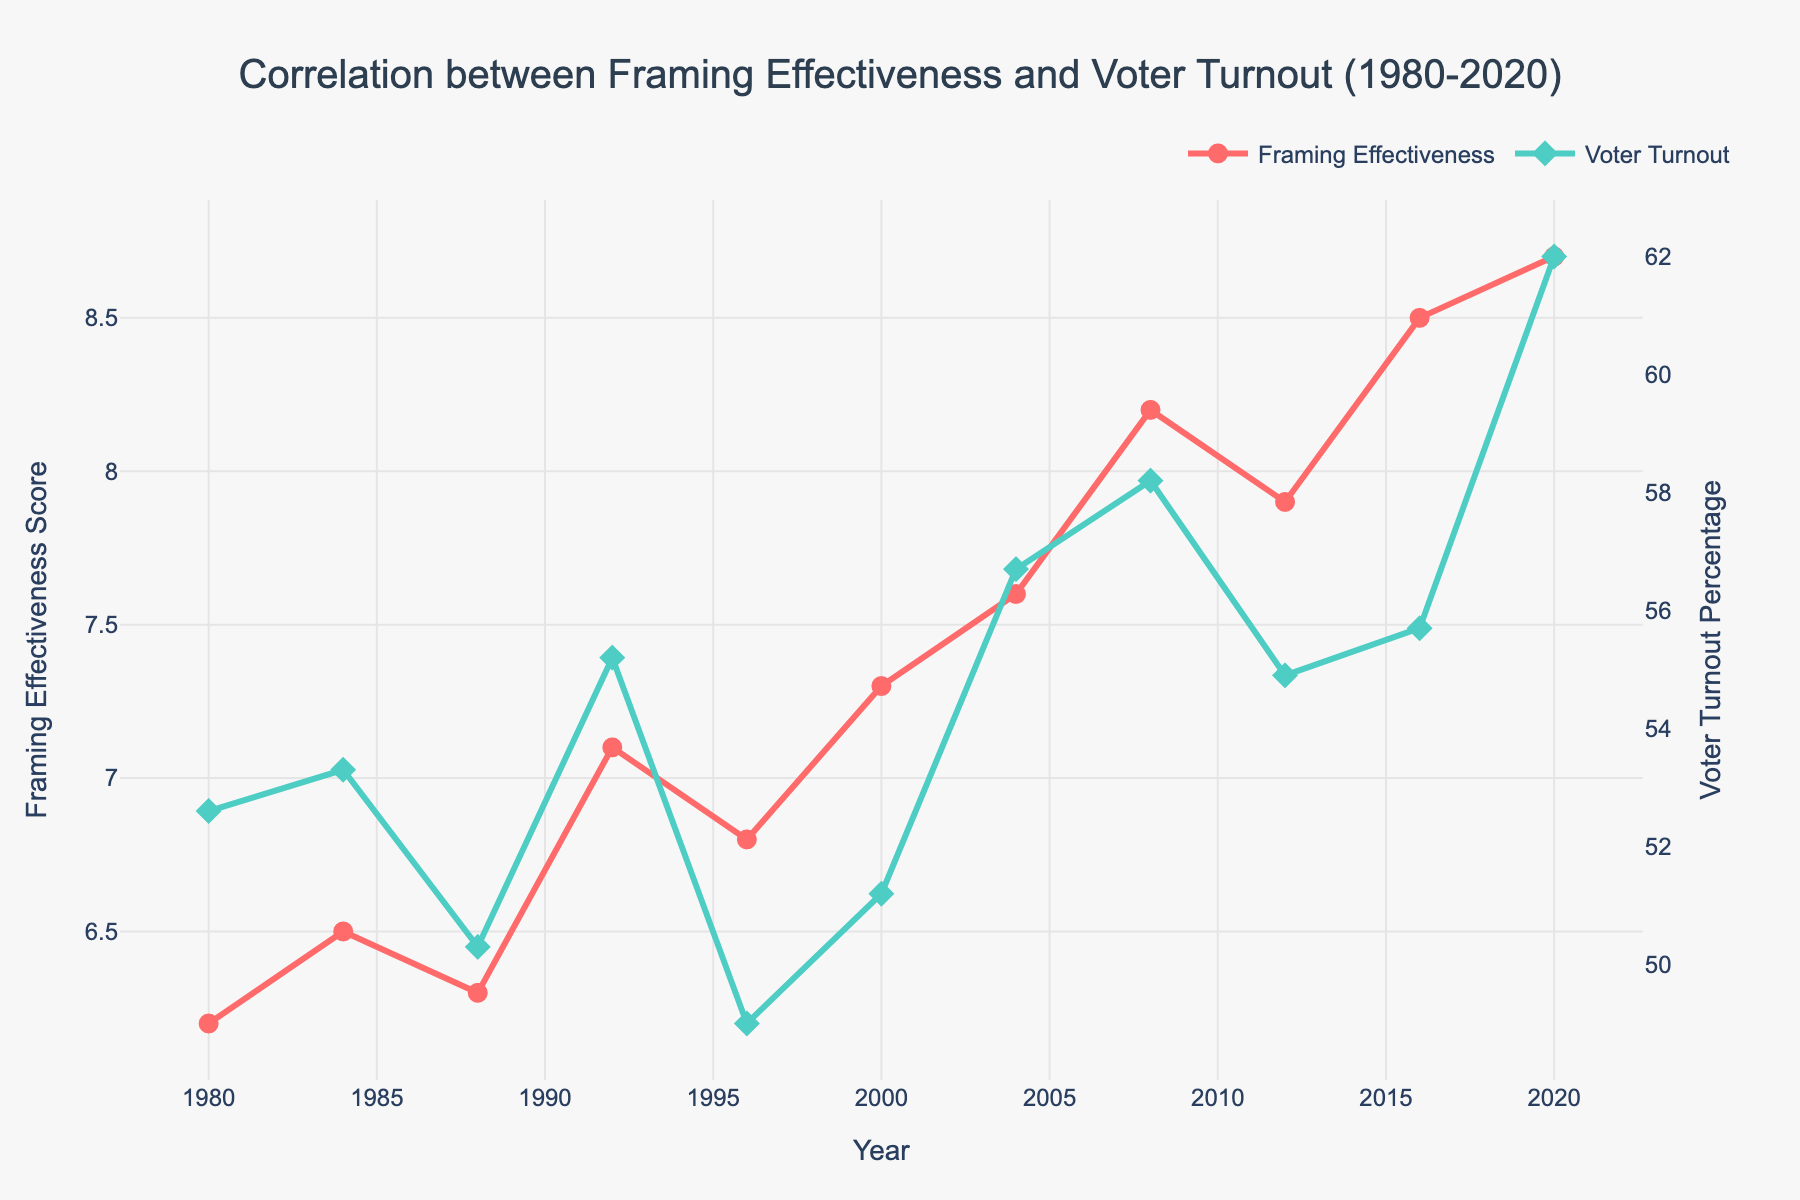What is the trend in the Framing Effectiveness Score from 1980 to 2020? The Framing Effectiveness Score increases gradually from 6.2 in 1980 to 8.7 in 2020.
Answer: Increasing Which year had the highest Voter Turnout Percentage? The year with the highest Voter Turnout Percentage is 2020 with a turnout of 62.0%.
Answer: 2020 In which year did the Framing Effectiveness Score see the largest increase from the previous election year? The largest increase in the Framing Effectiveness Score occurred from 1988 (6.3) to 1992 (7.1), which is an increase of 0.8.
Answer: 1992 Compare the Voter Turnout in 2008 and 2016. Which year had a higher turnout? The Voter Turnout in 2008 was 58.2%, while in 2016 it was 55.7%. Thus, 2008 had a higher turnout.
Answer: 2008 What is the difference between the Voter Turnout Percentage and the Framing Effectiveness Score in 2020? The Voter Turnout Percentage in 2020 is 62.0% and the Framing Effectiveness Score is 8.7. The difference is 62.0 - 8.7 = 53.3.
Answer: 53.3 How did the Voter Turnout Percentage change from 1980 to 1996? From 1980 (52.6%) to 1996 (49.0%), the Voter Turnout Percentage decreased by 52.6 - 49.0 = 3.6%.
Answer: Decreased by 3.6% Between 1984 and 1988, what happens to the Framing Effectiveness Score and the Voter Turnout Percentage? The Framing Effectiveness Score decreases from 6.5 to 6.3, while the Voter Turnout Percentage also decreases from 53.3% to 50.3%.
Answer: Both decreased What is the average Framing Effectiveness Score from 1980 to 2020? The average Framing Effectiveness Score is calculated by summing the scores and dividing by the number of years. (6.2 + 6.5 + 6.3 + 7.1 + 6.8 + 7.3 + 7.6 + 8.2 + 7.9 + 8.5 + 8.7) / 11 ≈ 7.27
Answer: 7.27 Visually, how can you distinguish between the Framing Effectiveness Score and the Voter Turnout Percentage in the figure? The Framing Effectiveness Score is represented by red lines and circular markers, whereas the Voter Turnout Percentage is shown by green lines and diamond markers.
Answer: Color and marker type Which year shows a simultaneous peak in both Framing Effectiveness Score and Voter Turnout Percentage? The year 2020 shows a simultaneous peak in both Framing Effectiveness Score (8.7) and Voter Turnout Percentage (62.0%).
Answer: 2020 